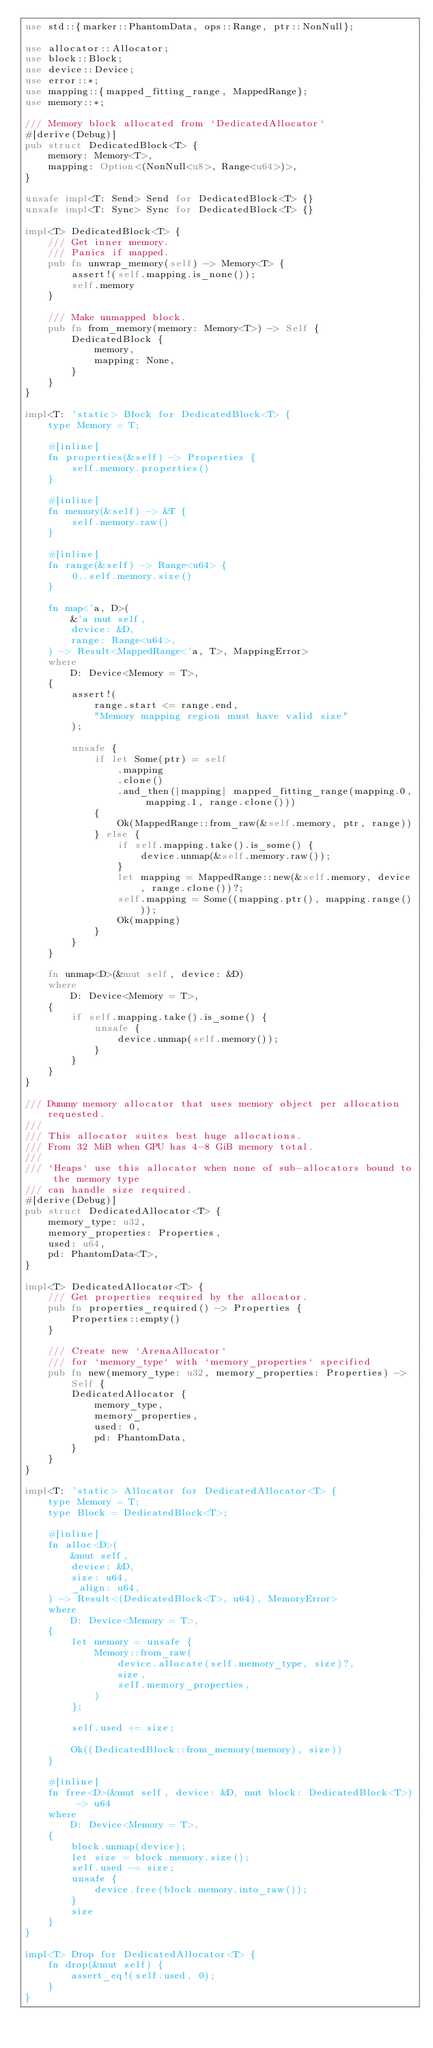<code> <loc_0><loc_0><loc_500><loc_500><_Rust_>use std::{marker::PhantomData, ops::Range, ptr::NonNull};

use allocator::Allocator;
use block::Block;
use device::Device;
use error::*;
use mapping::{mapped_fitting_range, MappedRange};
use memory::*;

/// Memory block allocated from `DedicatedAllocator`
#[derive(Debug)]
pub struct DedicatedBlock<T> {
    memory: Memory<T>,
    mapping: Option<(NonNull<u8>, Range<u64>)>,
}

unsafe impl<T: Send> Send for DedicatedBlock<T> {}
unsafe impl<T: Sync> Sync for DedicatedBlock<T> {}

impl<T> DedicatedBlock<T> {
    /// Get inner memory.
    /// Panics if mapped.
    pub fn unwrap_memory(self) -> Memory<T> {
        assert!(self.mapping.is_none());
        self.memory
    }

    /// Make unmapped block.
    pub fn from_memory(memory: Memory<T>) -> Self {
        DedicatedBlock {
            memory,
            mapping: None,
        }
    }
}

impl<T: 'static> Block for DedicatedBlock<T> {
    type Memory = T;

    #[inline]
    fn properties(&self) -> Properties {
        self.memory.properties()
    }

    #[inline]
    fn memory(&self) -> &T {
        self.memory.raw()
    }

    #[inline]
    fn range(&self) -> Range<u64> {
        0..self.memory.size()
    }

    fn map<'a, D>(
        &'a mut self,
        device: &D,
        range: Range<u64>,
    ) -> Result<MappedRange<'a, T>, MappingError>
    where
        D: Device<Memory = T>,
    {
        assert!(
            range.start <= range.end,
            "Memory mapping region must have valid size"
        );

        unsafe {
            if let Some(ptr) = self
                .mapping
                .clone()
                .and_then(|mapping| mapped_fitting_range(mapping.0, mapping.1, range.clone()))
            {
                Ok(MappedRange::from_raw(&self.memory, ptr, range))
            } else {
                if self.mapping.take().is_some() {
                    device.unmap(&self.memory.raw());
                }
                let mapping = MappedRange::new(&self.memory, device, range.clone())?;
                self.mapping = Some((mapping.ptr(), mapping.range()));
                Ok(mapping)
            }
        }
    }

    fn unmap<D>(&mut self, device: &D)
    where
        D: Device<Memory = T>,
    {
        if self.mapping.take().is_some() {
            unsafe {
                device.unmap(self.memory());
            }
        }
    }
}

/// Dummy memory allocator that uses memory object per allocation requested.
///
/// This allocator suites best huge allocations.
/// From 32 MiB when GPU has 4-8 GiB memory total.
///
/// `Heaps` use this allocator when none of sub-allocators bound to the memory type
/// can handle size required.
#[derive(Debug)]
pub struct DedicatedAllocator<T> {
    memory_type: u32,
    memory_properties: Properties,
    used: u64,
    pd: PhantomData<T>,
}

impl<T> DedicatedAllocator<T> {
    /// Get properties required by the allocator.
    pub fn properties_required() -> Properties {
        Properties::empty()
    }

    /// Create new `ArenaAllocator`
    /// for `memory_type` with `memory_properties` specified
    pub fn new(memory_type: u32, memory_properties: Properties) -> Self {
        DedicatedAllocator {
            memory_type,
            memory_properties,
            used: 0,
            pd: PhantomData,
        }
    }
}

impl<T: 'static> Allocator for DedicatedAllocator<T> {
    type Memory = T;
    type Block = DedicatedBlock<T>;

    #[inline]
    fn alloc<D>(
        &mut self,
        device: &D,
        size: u64,
        _align: u64,
    ) -> Result<(DedicatedBlock<T>, u64), MemoryError>
    where
        D: Device<Memory = T>,
    {
        let memory = unsafe {
            Memory::from_raw(
                device.allocate(self.memory_type, size)?,
                size,
                self.memory_properties,
            )
        };

        self.used += size;

        Ok((DedicatedBlock::from_memory(memory), size))
    }

    #[inline]
    fn free<D>(&mut self, device: &D, mut block: DedicatedBlock<T>) -> u64
    where
        D: Device<Memory = T>,
    {
        block.unmap(device);
        let size = block.memory.size();
        self.used -= size;
        unsafe {
            device.free(block.memory.into_raw());
        }
        size
    }
}

impl<T> Drop for DedicatedAllocator<T> {
    fn drop(&mut self) {
        assert_eq!(self.used, 0);
    }
}
</code> 